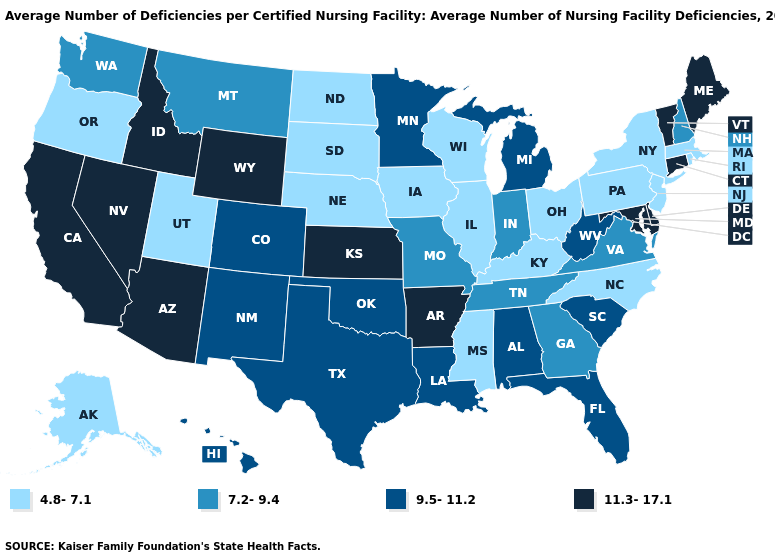Is the legend a continuous bar?
Quick response, please. No. What is the highest value in the USA?
Concise answer only. 11.3-17.1. What is the value of Alabama?
Give a very brief answer. 9.5-11.2. Which states have the lowest value in the USA?
Answer briefly. Alaska, Illinois, Iowa, Kentucky, Massachusetts, Mississippi, Nebraska, New Jersey, New York, North Carolina, North Dakota, Ohio, Oregon, Pennsylvania, Rhode Island, South Dakota, Utah, Wisconsin. Does the first symbol in the legend represent the smallest category?
Answer briefly. Yes. What is the value of Wyoming?
Quick response, please. 11.3-17.1. What is the value of Minnesota?
Write a very short answer. 9.5-11.2. Which states have the lowest value in the USA?
Write a very short answer. Alaska, Illinois, Iowa, Kentucky, Massachusetts, Mississippi, Nebraska, New Jersey, New York, North Carolina, North Dakota, Ohio, Oregon, Pennsylvania, Rhode Island, South Dakota, Utah, Wisconsin. Name the states that have a value in the range 11.3-17.1?
Give a very brief answer. Arizona, Arkansas, California, Connecticut, Delaware, Idaho, Kansas, Maine, Maryland, Nevada, Vermont, Wyoming. How many symbols are there in the legend?
Write a very short answer. 4. What is the value of Pennsylvania?
Quick response, please. 4.8-7.1. Does Vermont have the highest value in the USA?
Concise answer only. Yes. Does Idaho have the highest value in the USA?
Quick response, please. Yes. Does the map have missing data?
Write a very short answer. No. Name the states that have a value in the range 9.5-11.2?
Write a very short answer. Alabama, Colorado, Florida, Hawaii, Louisiana, Michigan, Minnesota, New Mexico, Oklahoma, South Carolina, Texas, West Virginia. 